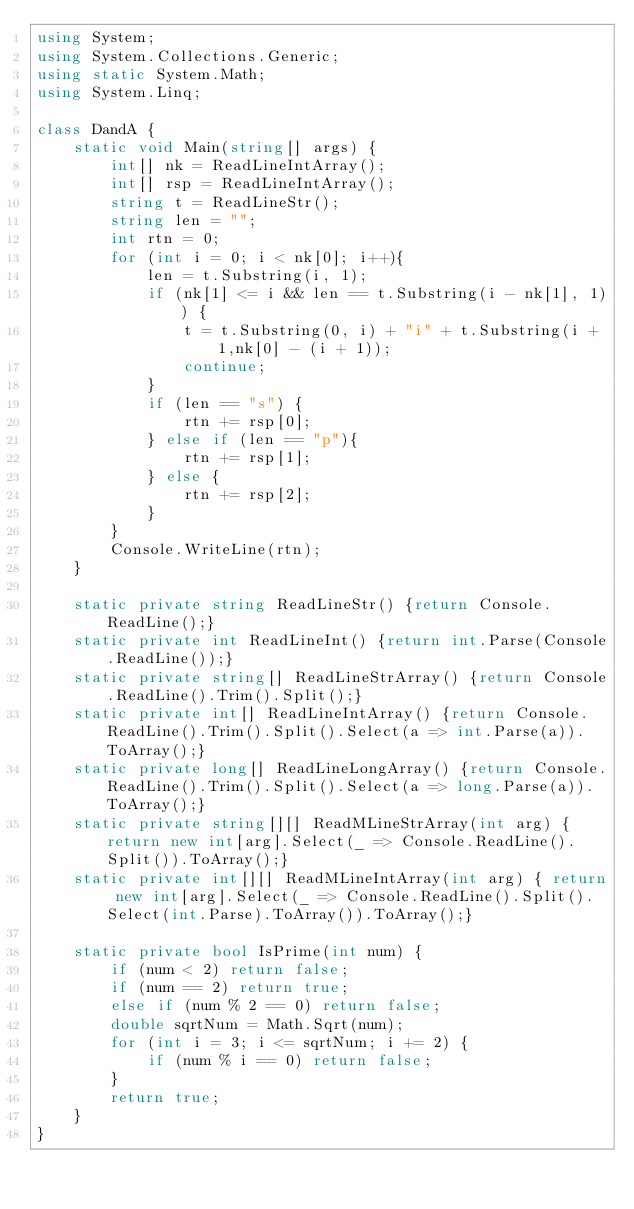Convert code to text. <code><loc_0><loc_0><loc_500><loc_500><_C#_>using System;
using System.Collections.Generic;
using static System.Math;
using System.Linq;
 
class DandA {
    static void Main(string[] args) {
        int[] nk = ReadLineIntArray();
        int[] rsp = ReadLineIntArray();
        string t = ReadLineStr();
        string len = "";
        int rtn = 0;
        for (int i = 0; i < nk[0]; i++){
            len = t.Substring(i, 1);
            if (nk[1] <= i && len == t.Substring(i - nk[1], 1)) {
                t = t.Substring(0, i) + "i" + t.Substring(i + 1,nk[0] - (i + 1));
                continue;
            }
            if (len == "s") {
                rtn += rsp[0];
            } else if (len == "p"){
                rtn += rsp[1];
            } else {
                rtn += rsp[2];
            }
        }
        Console.WriteLine(rtn);
    }
  
    static private string ReadLineStr() {return Console.ReadLine();}
    static private int ReadLineInt() {return int.Parse(Console.ReadLine());}
    static private string[] ReadLineStrArray() {return Console.ReadLine().Trim().Split();}
    static private int[] ReadLineIntArray() {return Console.ReadLine().Trim().Split().Select(a => int.Parse(a)).ToArray();}
    static private long[] ReadLineLongArray() {return Console.ReadLine().Trim().Split().Select(a => long.Parse(a)).ToArray();}
    static private string[][] ReadMLineStrArray(int arg) { return new int[arg].Select(_ => Console.ReadLine().Split()).ToArray();}
    static private int[][] ReadMLineIntArray(int arg) { return new int[arg].Select(_ => Console.ReadLine().Split().Select(int.Parse).ToArray()).ToArray();}

    static private bool IsPrime(int num) {
        if (num < 2) return false;
        if (num == 2) return true;
        else if (num % 2 == 0) return false;
        double sqrtNum = Math.Sqrt(num);
        for (int i = 3; i <= sqrtNum; i += 2) {
            if (num % i == 0) return false;
        }
        return true;
    }
}</code> 